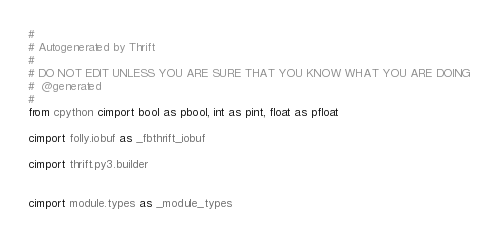Convert code to text. <code><loc_0><loc_0><loc_500><loc_500><_Cython_>#
# Autogenerated by Thrift
#
# DO NOT EDIT UNLESS YOU ARE SURE THAT YOU KNOW WHAT YOU ARE DOING
#  @generated
#
from cpython cimport bool as pbool, int as pint, float as pfloat

cimport folly.iobuf as _fbthrift_iobuf

cimport thrift.py3.builder


cimport module.types as _module_types

</code> 